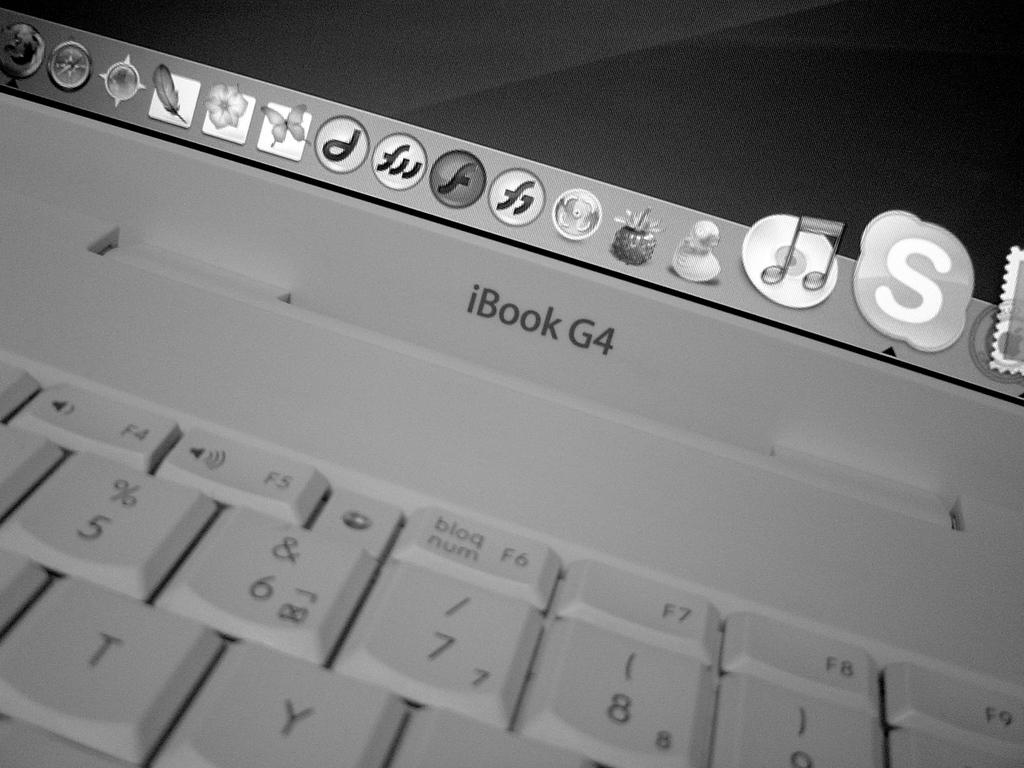Provide a one-sentence caption for the provided image. An iBook G4 sits open with many apps displayed. 